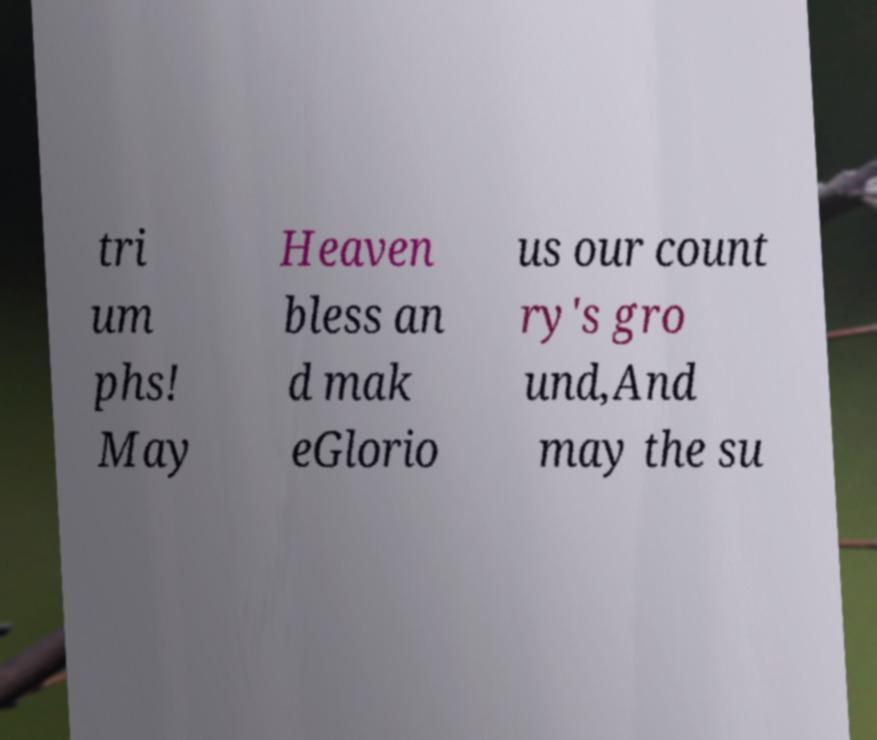Please read and relay the text visible in this image. What does it say? tri um phs! May Heaven bless an d mak eGlorio us our count ry's gro und,And may the su 